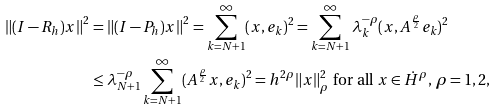Convert formula to latex. <formula><loc_0><loc_0><loc_500><loc_500>\left \| ( I - R _ { h } ) x \right \| ^ { 2 } & = \left \| ( I - P _ { h } ) x \right \| ^ { 2 } = \sum _ { k = N + 1 } ^ { \infty } ( x , e _ { k } ) ^ { 2 } = \sum _ { k = N + 1 } ^ { \infty } \lambda _ { k } ^ { - \rho } ( x , A ^ { \frac { \rho } { 2 } } e _ { k } ) ^ { 2 } \\ & \leq \lambda _ { N + 1 } ^ { - \rho } \sum _ { k = N + 1 } ^ { \infty } ( A ^ { \frac { \rho } { 2 } } x , e _ { k } ) ^ { 2 } = h ^ { 2 \rho } \| x \| _ { \rho } ^ { 2 } \text { for all } x \in \dot { H } ^ { \rho } , \, \rho = 1 , 2 ,</formula> 